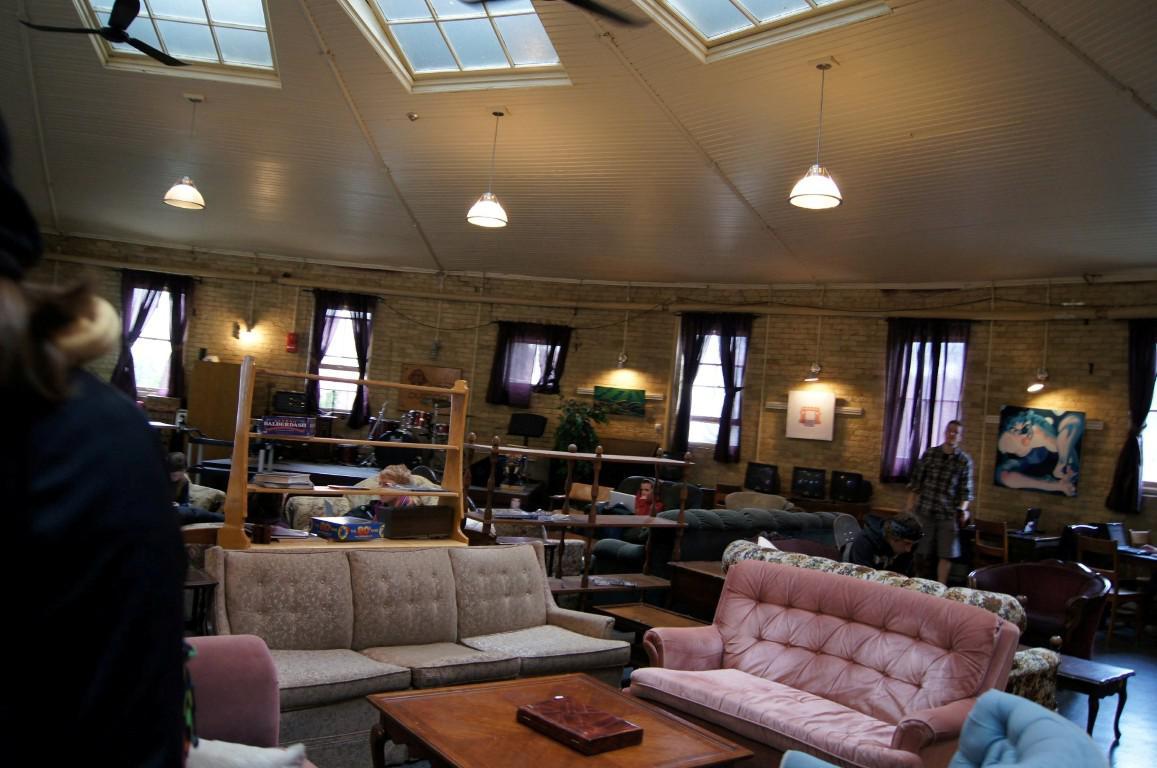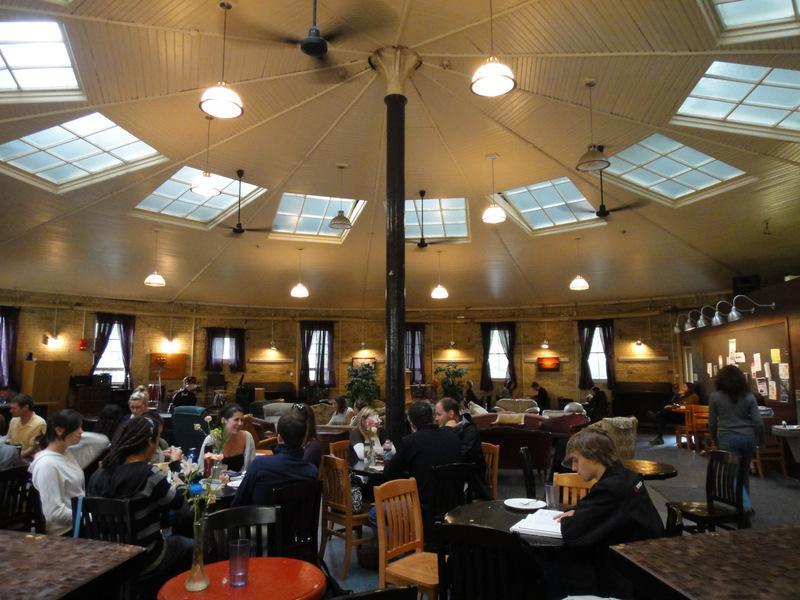The first image is the image on the left, the second image is the image on the right. For the images displayed, is the sentence "One image shows an interior with a black column in the center, dome-shaped suspended lights, and paned square windows in the ceiling." factually correct? Answer yes or no. Yes. The first image is the image on the left, the second image is the image on the right. Assess this claim about the two images: "There are both bar stools and chairs.". Correct or not? Answer yes or no. No. 